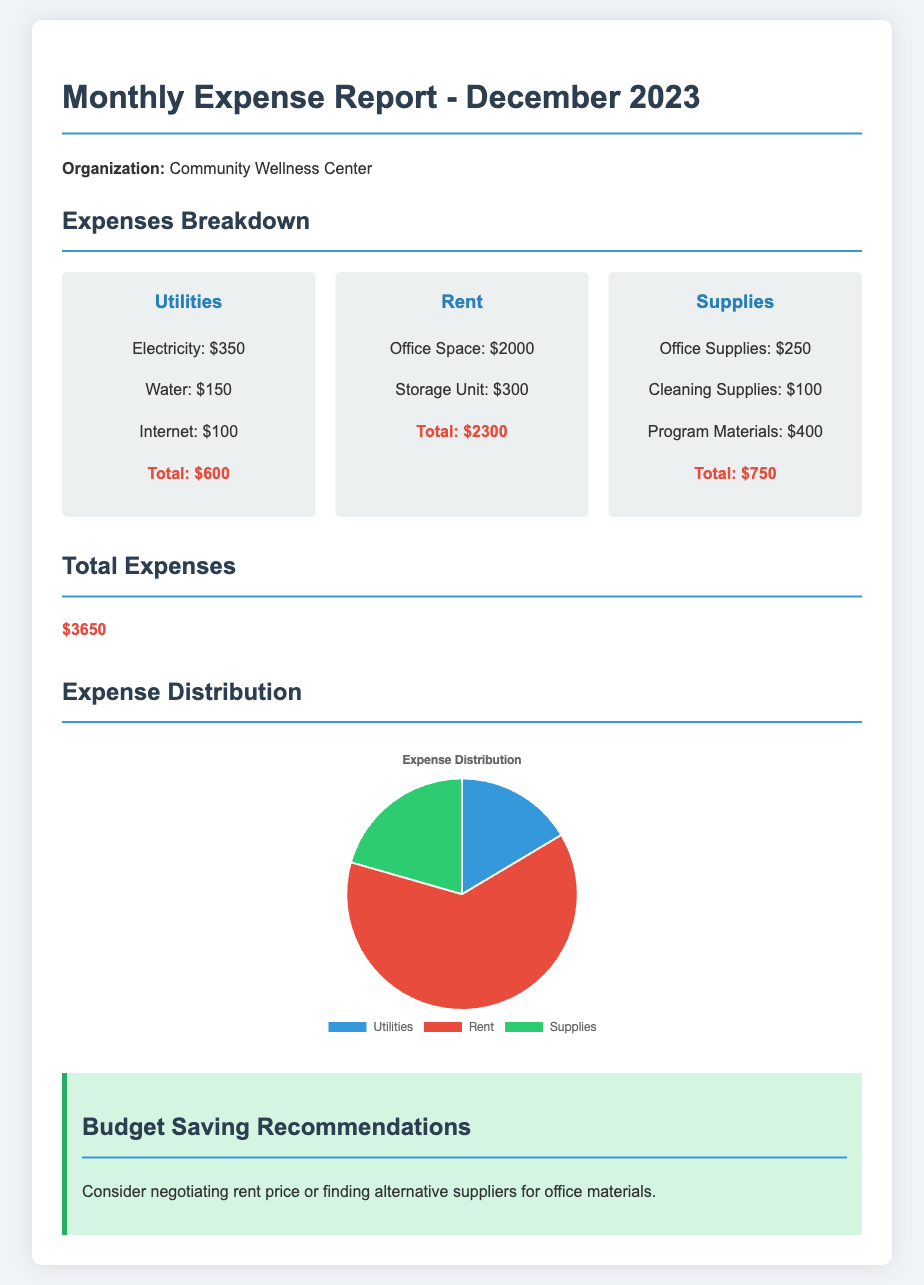What is the total amount spent on utilities? The total amount spent on utilities is listed directly in the report under the Utilities section, which is $600.
Answer: $600 What is the total rent expense? The total rent expense can be found in the Rent section, specifically accounting for both the office space and storage unit, which totals $2300.
Answer: $2300 How much was spent on office supplies? The amount spent on office supplies is detailed under the Supplies section as $250.
Answer: $250 What category had the highest expense? By comparing the totals in each category, Rent is identified as having the highest expense at $2300.
Answer: Rent What is the total of all expenses? The total of all expenses is explicitly stated in the Total Expenses section, amounting to $3650.
Answer: $3650 What is the color representing supplies in the pie chart? The chart indicates that supplies are represented by the color green.
Answer: Green What is a recommended action to save on the budget? The document suggests negotiating the rent price as a potential way to save on the budget.
Answer: Negotiating rent price How many types of expenses are detailed in the report? The report categorizes expenses into three types: Utilities, Rent, and Supplies.
Answer: Three What is the purpose of the expense chart? The expense chart is used to visually depict the distribution of expenses among the different categories.
Answer: Visual depiction of expense distribution 